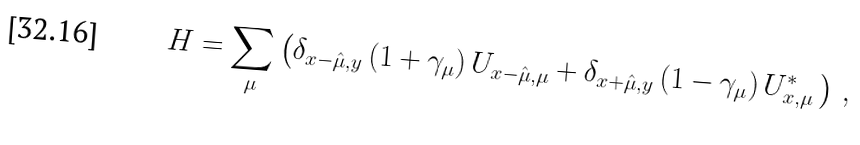<formula> <loc_0><loc_0><loc_500><loc_500>H = \sum _ { \mu } \left ( \delta _ { x - \hat { \mu } , y } \, ( 1 + \gamma _ { \mu } ) \, U _ { x - \hat { \mu } , \mu } + \delta _ { x + \hat { \mu } , y } \, ( 1 - \gamma _ { \mu } ) \, U _ { x , \mu } ^ { * } \, \right ) \, ,</formula> 